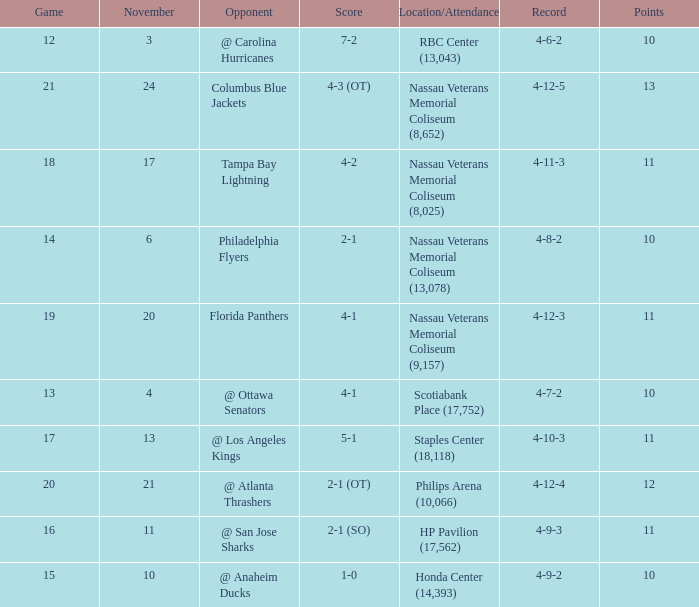What is the least amount of points? 10.0. 